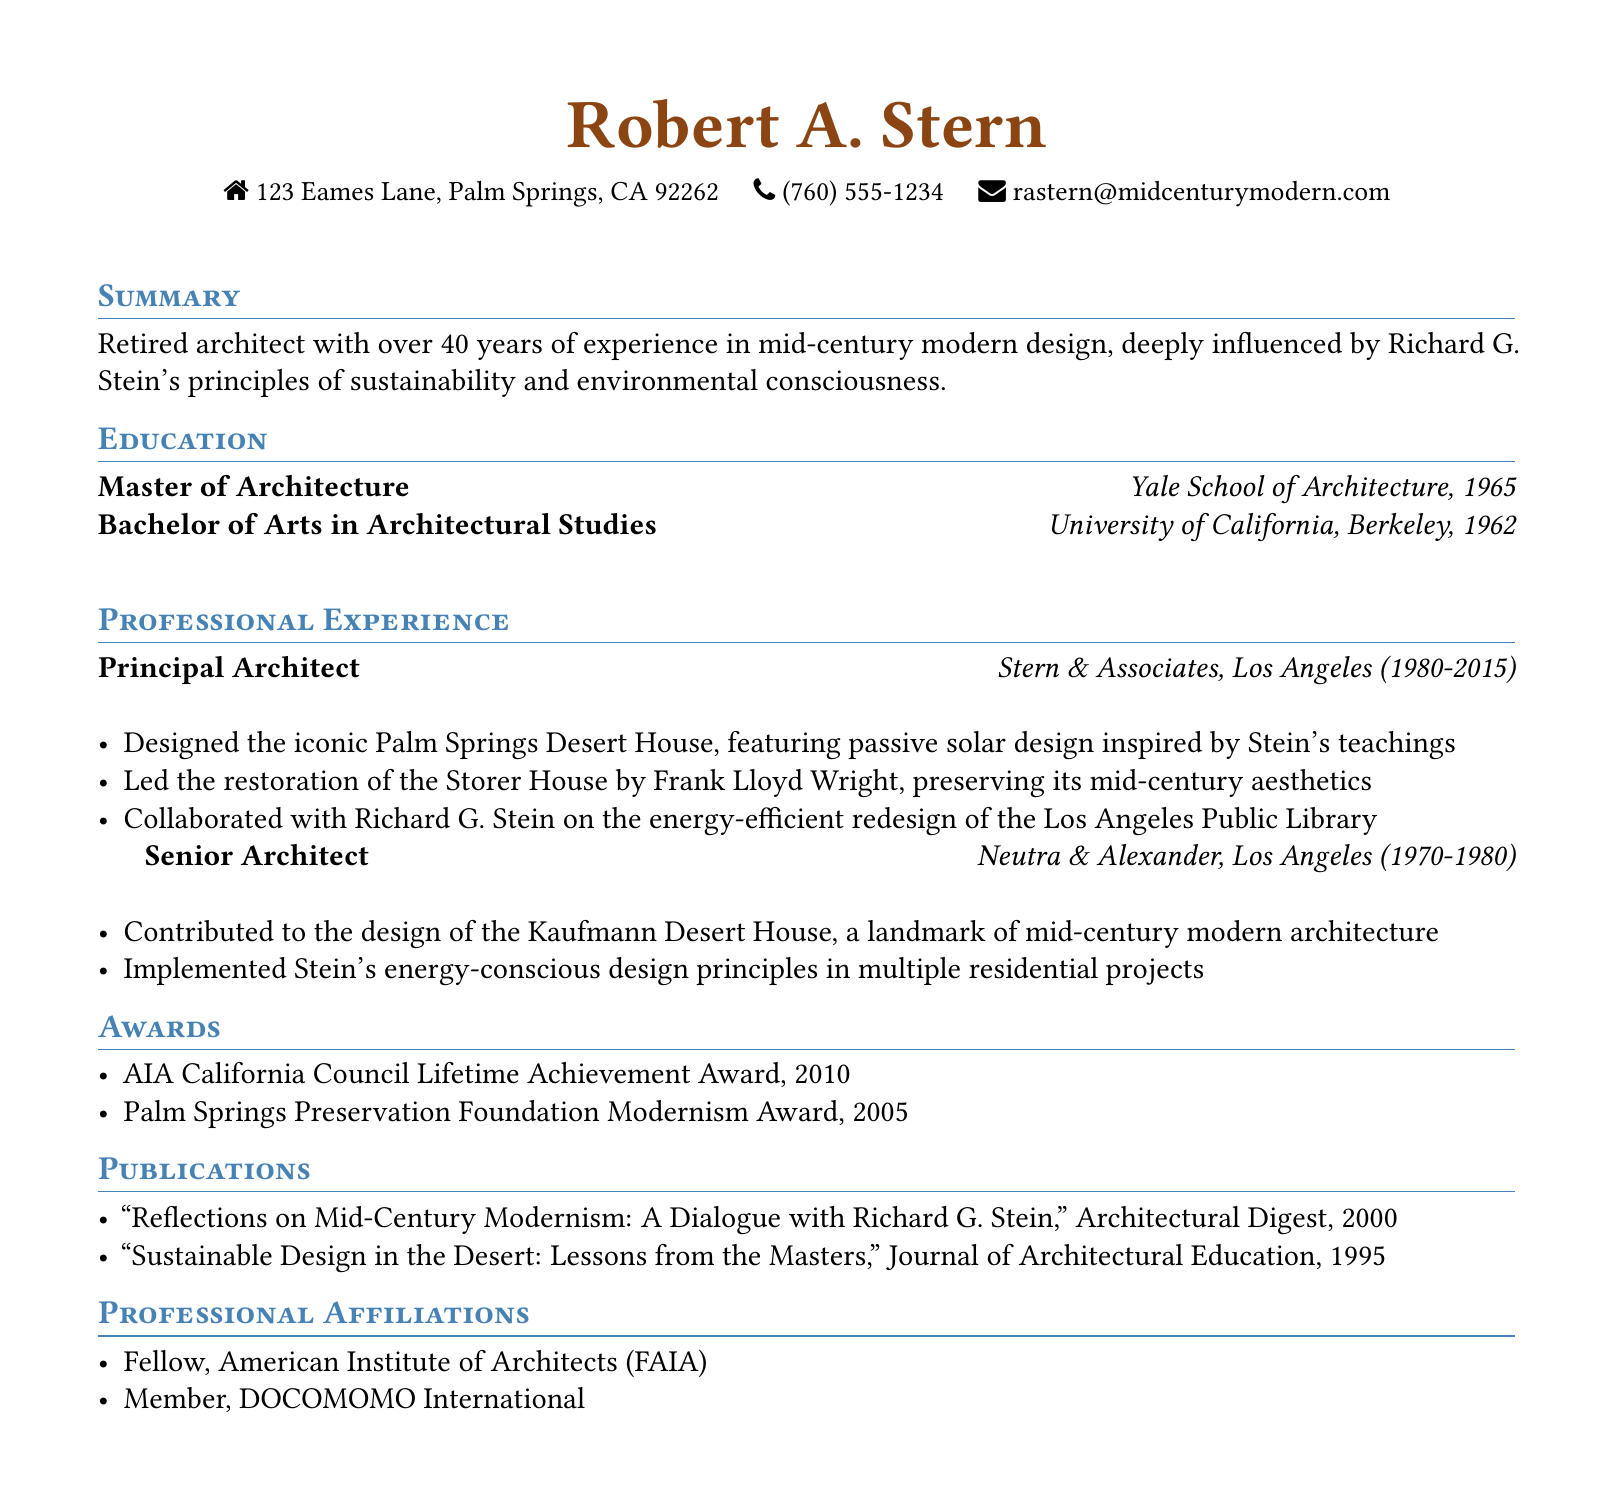What is the name of the architect? The document prominently features the name of the architect at the top.
Answer: Robert A. Stern What degree did Robert A. Stern earn in 1965? The education section lists the degrees and their years of completion.
Answer: Master of Architecture In which city was Stern & Associates located? The work experience section indicates the location of Stern & Associates.
Answer: Los Angeles What award did he receive in 2010? The awards section mentions the specific awards received and their corresponding years.
Answer: AIA California Council Lifetime Achievement Award What is one of Robert A. Stern's publications? The publications section provides titles of articles written by Robert A. Stern.
Answer: Reflections on Mid-Century Modernism: A Dialogue with Richard G. Stein Which influential architect did Stern collaborate with on the Los Angeles Public Library redesign? The work experience section references the collaboration on a significant project.
Answer: Richard G. Stein How many years did Robert A. Stern work at Stern & Associates? The work experience section specifies the years of employment at each position.
Answer: 35 years What professional affiliation does Robert A. Stern hold? The professional affiliations section lists his memberships in professional organizations.
Answer: Fellow, American Institute of Architects (FAIA) What principle influenced Stern's architectural designs? The summary section describes his design philosophy.
Answer: Sustainability and environmental consciousness 